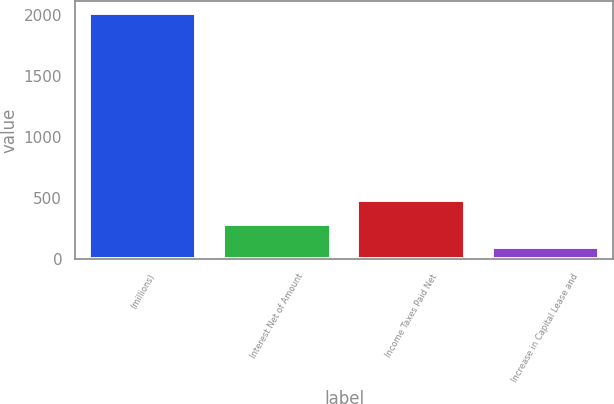Convert chart to OTSL. <chart><loc_0><loc_0><loc_500><loc_500><bar_chart><fcel>(millions)<fcel>Interest Net of Amount<fcel>Income Taxes Paid Net<fcel>Increase in Capital Lease and<nl><fcel>2013<fcel>287.7<fcel>479.4<fcel>96<nl></chart> 